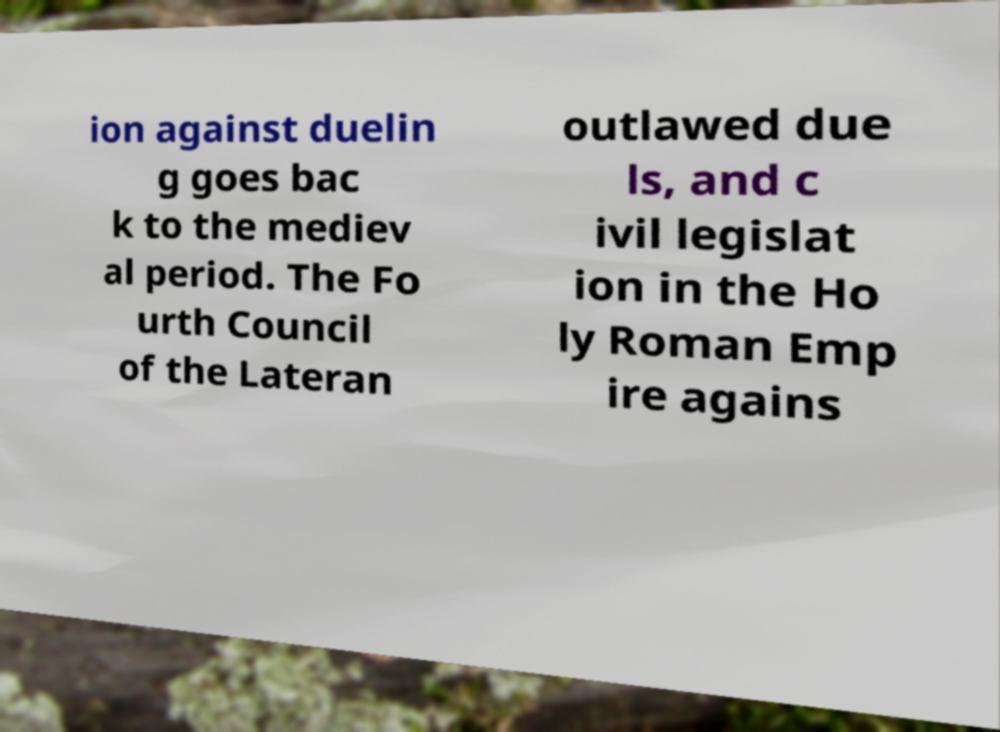I need the written content from this picture converted into text. Can you do that? ion against duelin g goes bac k to the mediev al period. The Fo urth Council of the Lateran outlawed due ls, and c ivil legislat ion in the Ho ly Roman Emp ire agains 